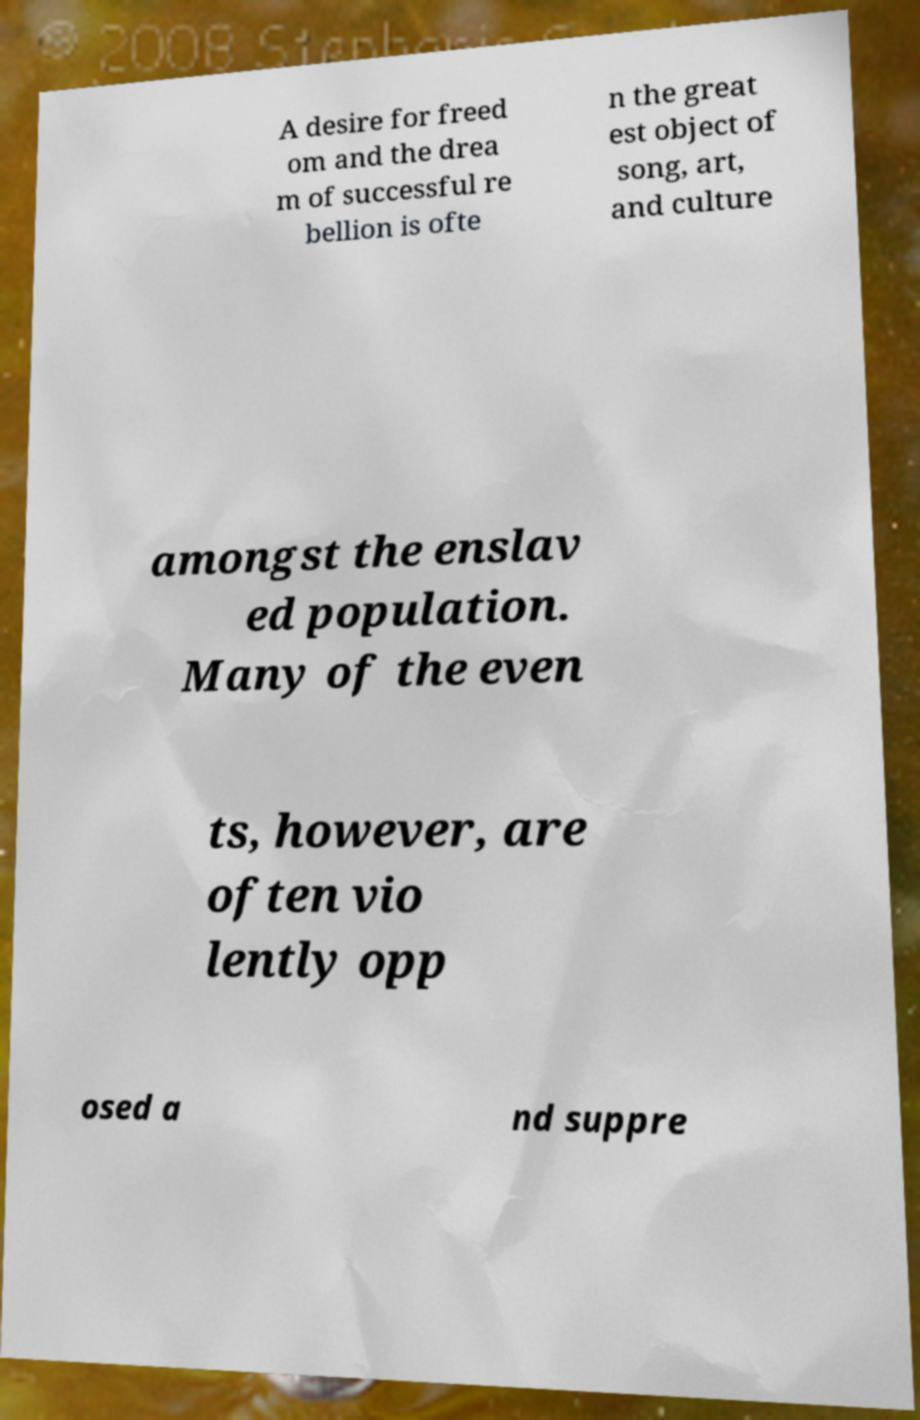For documentation purposes, I need the text within this image transcribed. Could you provide that? A desire for freed om and the drea m of successful re bellion is ofte n the great est object of song, art, and culture amongst the enslav ed population. Many of the even ts, however, are often vio lently opp osed a nd suppre 